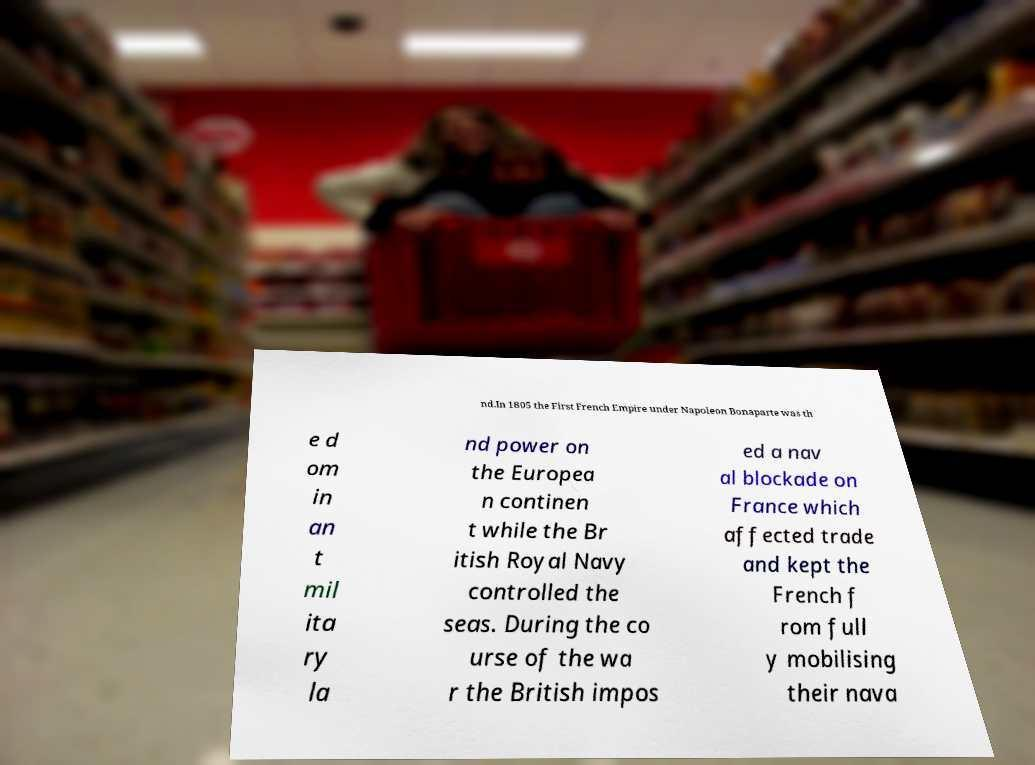There's text embedded in this image that I need extracted. Can you transcribe it verbatim? nd.In 1805 the First French Empire under Napoleon Bonaparte was th e d om in an t mil ita ry la nd power on the Europea n continen t while the Br itish Royal Navy controlled the seas. During the co urse of the wa r the British impos ed a nav al blockade on France which affected trade and kept the French f rom full y mobilising their nava 